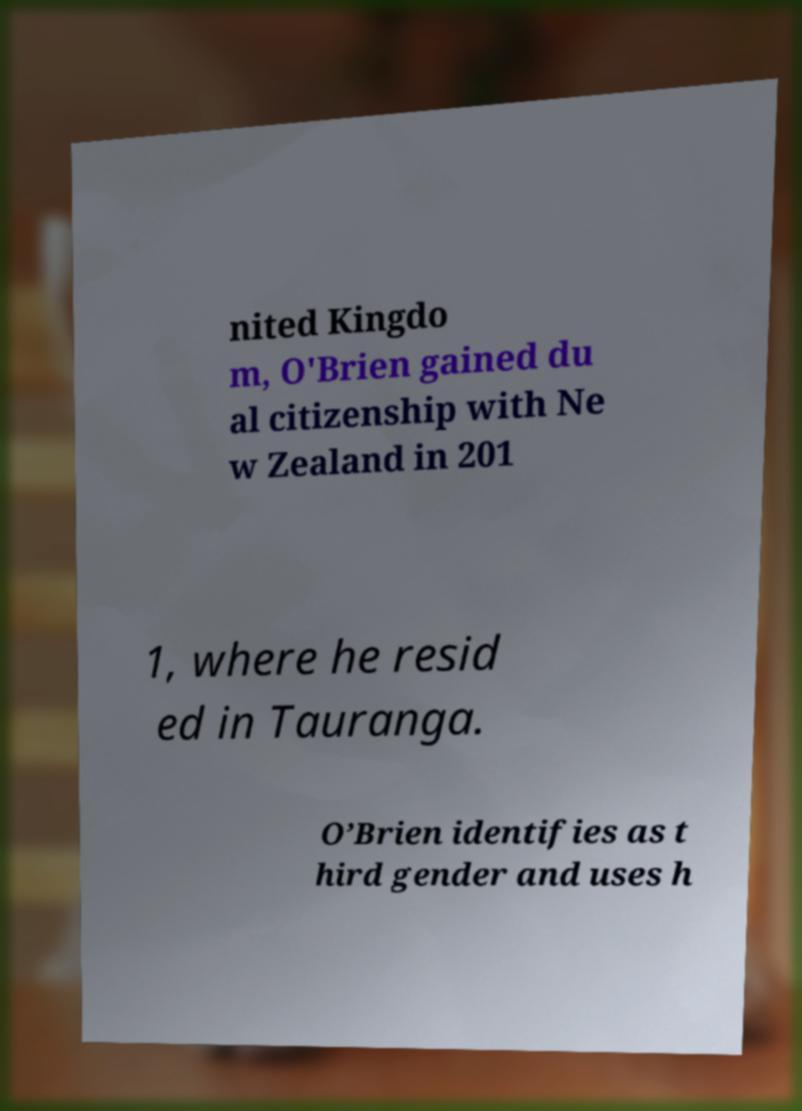For documentation purposes, I need the text within this image transcribed. Could you provide that? nited Kingdo m, O'Brien gained du al citizenship with Ne w Zealand in 201 1, where he resid ed in Tauranga. O’Brien identifies as t hird gender and uses h 